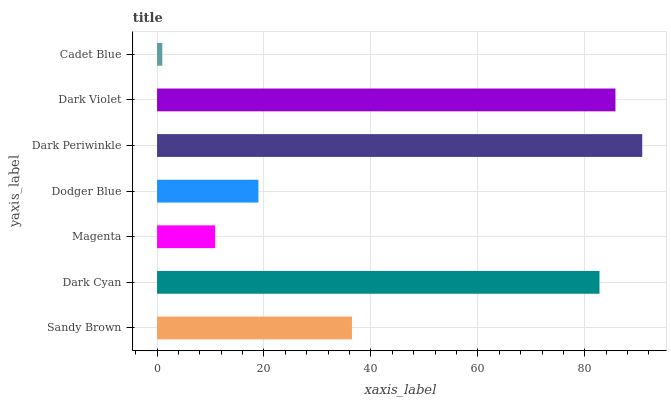Is Cadet Blue the minimum?
Answer yes or no. Yes. Is Dark Periwinkle the maximum?
Answer yes or no. Yes. Is Dark Cyan the minimum?
Answer yes or no. No. Is Dark Cyan the maximum?
Answer yes or no. No. Is Dark Cyan greater than Sandy Brown?
Answer yes or no. Yes. Is Sandy Brown less than Dark Cyan?
Answer yes or no. Yes. Is Sandy Brown greater than Dark Cyan?
Answer yes or no. No. Is Dark Cyan less than Sandy Brown?
Answer yes or no. No. Is Sandy Brown the high median?
Answer yes or no. Yes. Is Sandy Brown the low median?
Answer yes or no. Yes. Is Dark Periwinkle the high median?
Answer yes or no. No. Is Dark Periwinkle the low median?
Answer yes or no. No. 